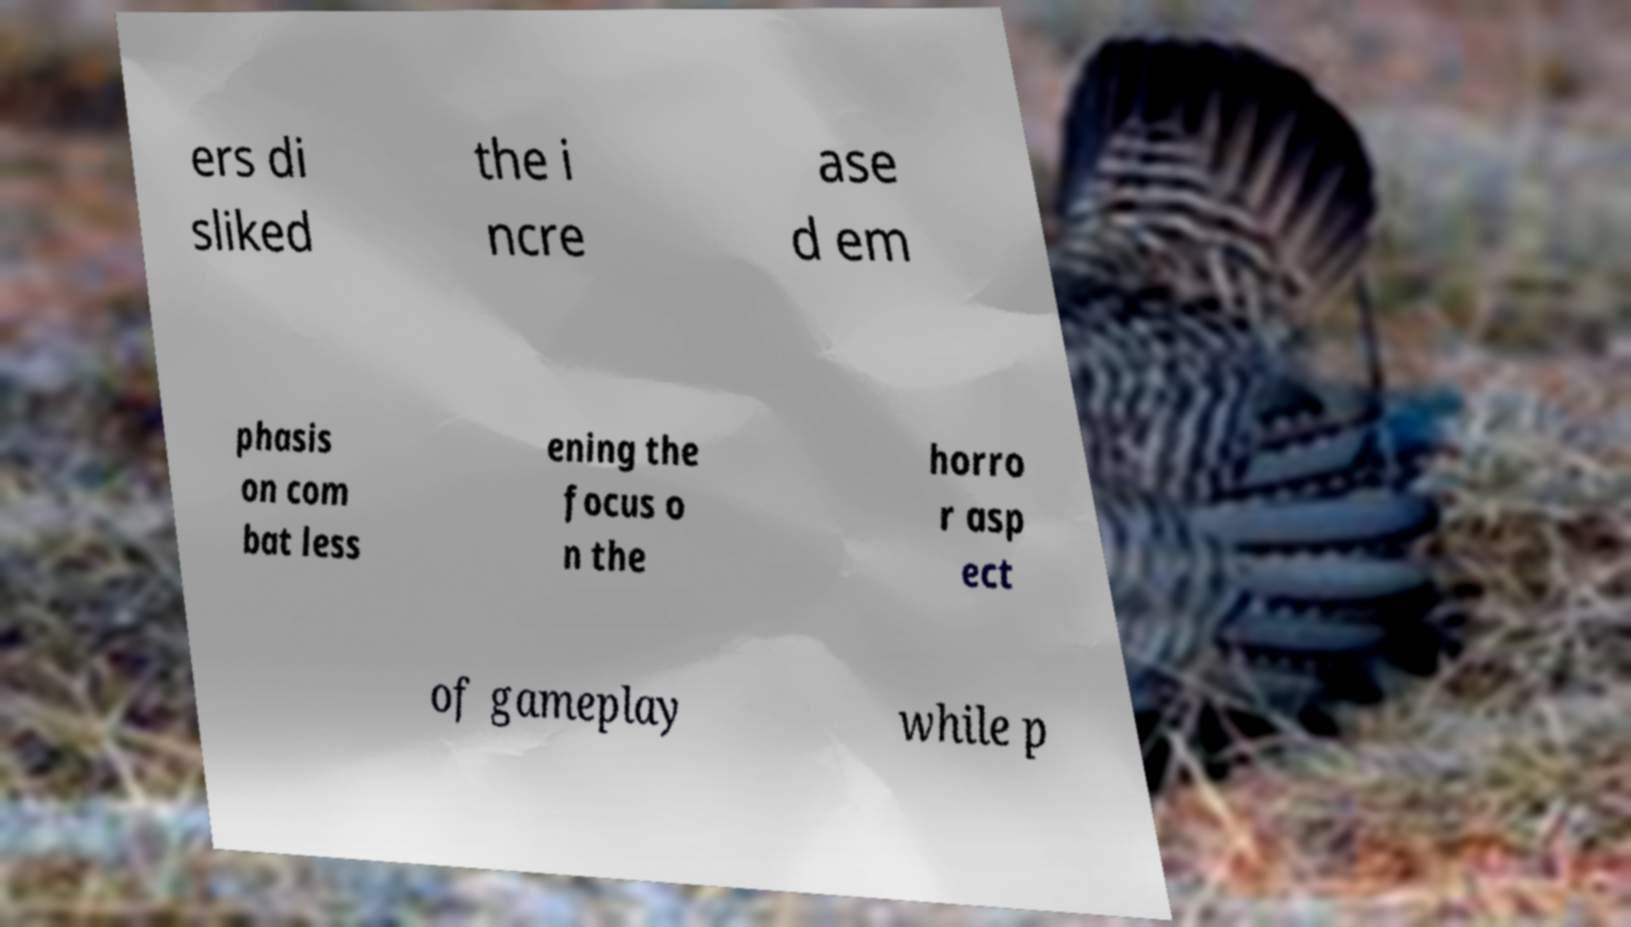Can you read and provide the text displayed in the image?This photo seems to have some interesting text. Can you extract and type it out for me? ers di sliked the i ncre ase d em phasis on com bat less ening the focus o n the horro r asp ect of gameplay while p 